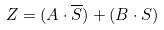Convert formula to latex. <formula><loc_0><loc_0><loc_500><loc_500>Z = ( A \cdot \overline { S } ) + ( B \cdot S )</formula> 